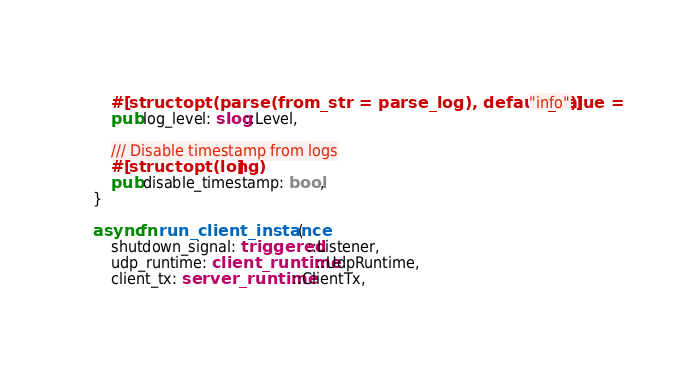Convert code to text. <code><loc_0><loc_0><loc_500><loc_500><_Rust_>    #[structopt(parse(from_str = parse_log), default_value = "info")]
    pub log_level: slog::Level,

    /// Disable timestamp from logs
    #[structopt(long)]
    pub disable_timestamp: bool,
}

async fn run_client_instance(
    shutdown_signal: triggered::Listener,
    udp_runtime: client_runtime::UdpRuntime,
    client_tx: server_runtime::ClientTx,</code> 